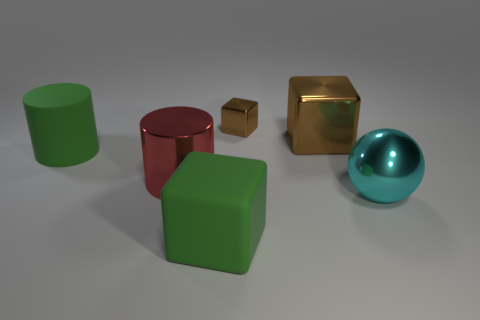Is there any other thing that is the same shape as the large brown shiny object?
Offer a very short reply. Yes. Is the material of the big green thing left of the red metal cylinder the same as the big green cube?
Give a very brief answer. Yes. What is the material of the green block that is the same size as the green rubber cylinder?
Offer a very short reply. Rubber. How many other objects are the same material as the large cyan object?
Ensure brevity in your answer.  3. Do the matte cylinder and the brown block to the left of the large brown block have the same size?
Offer a very short reply. No. Are there fewer big brown blocks that are on the left side of the green cylinder than cyan metallic things left of the green rubber cube?
Offer a terse response. No. How big is the green thing behind the big cyan sphere?
Offer a terse response. Large. How many big shiny things are in front of the large brown shiny block and right of the large red shiny cylinder?
Provide a succinct answer. 1. What number of yellow things are either large cylinders or metallic objects?
Offer a terse response. 0. How many rubber things are either tiny purple objects or red cylinders?
Offer a very short reply. 0. 